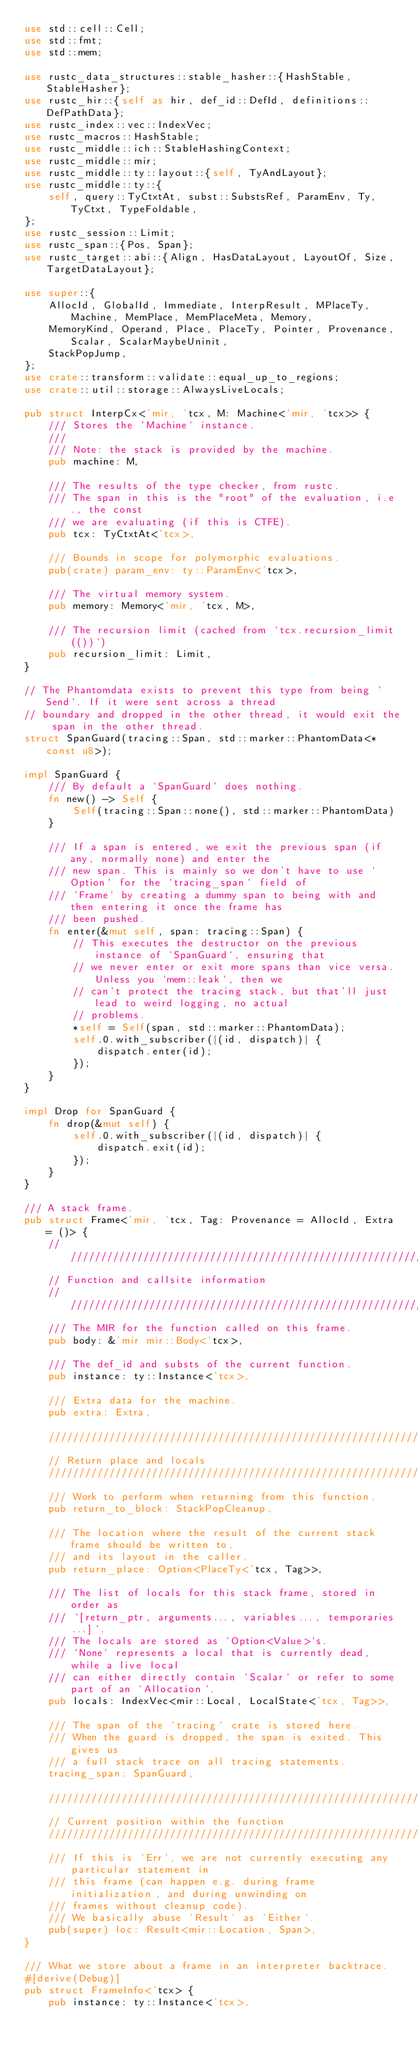Convert code to text. <code><loc_0><loc_0><loc_500><loc_500><_Rust_>use std::cell::Cell;
use std::fmt;
use std::mem;

use rustc_data_structures::stable_hasher::{HashStable, StableHasher};
use rustc_hir::{self as hir, def_id::DefId, definitions::DefPathData};
use rustc_index::vec::IndexVec;
use rustc_macros::HashStable;
use rustc_middle::ich::StableHashingContext;
use rustc_middle::mir;
use rustc_middle::ty::layout::{self, TyAndLayout};
use rustc_middle::ty::{
    self, query::TyCtxtAt, subst::SubstsRef, ParamEnv, Ty, TyCtxt, TypeFoldable,
};
use rustc_session::Limit;
use rustc_span::{Pos, Span};
use rustc_target::abi::{Align, HasDataLayout, LayoutOf, Size, TargetDataLayout};

use super::{
    AllocId, GlobalId, Immediate, InterpResult, MPlaceTy, Machine, MemPlace, MemPlaceMeta, Memory,
    MemoryKind, Operand, Place, PlaceTy, Pointer, Provenance, Scalar, ScalarMaybeUninit,
    StackPopJump,
};
use crate::transform::validate::equal_up_to_regions;
use crate::util::storage::AlwaysLiveLocals;

pub struct InterpCx<'mir, 'tcx, M: Machine<'mir, 'tcx>> {
    /// Stores the `Machine` instance.
    ///
    /// Note: the stack is provided by the machine.
    pub machine: M,

    /// The results of the type checker, from rustc.
    /// The span in this is the "root" of the evaluation, i.e., the const
    /// we are evaluating (if this is CTFE).
    pub tcx: TyCtxtAt<'tcx>,

    /// Bounds in scope for polymorphic evaluations.
    pub(crate) param_env: ty::ParamEnv<'tcx>,

    /// The virtual memory system.
    pub memory: Memory<'mir, 'tcx, M>,

    /// The recursion limit (cached from `tcx.recursion_limit(())`)
    pub recursion_limit: Limit,
}

// The Phantomdata exists to prevent this type from being `Send`. If it were sent across a thread
// boundary and dropped in the other thread, it would exit the span in the other thread.
struct SpanGuard(tracing::Span, std::marker::PhantomData<*const u8>);

impl SpanGuard {
    /// By default a `SpanGuard` does nothing.
    fn new() -> Self {
        Self(tracing::Span::none(), std::marker::PhantomData)
    }

    /// If a span is entered, we exit the previous span (if any, normally none) and enter the
    /// new span. This is mainly so we don't have to use `Option` for the `tracing_span` field of
    /// `Frame` by creating a dummy span to being with and then entering it once the frame has
    /// been pushed.
    fn enter(&mut self, span: tracing::Span) {
        // This executes the destructor on the previous instance of `SpanGuard`, ensuring that
        // we never enter or exit more spans than vice versa. Unless you `mem::leak`, then we
        // can't protect the tracing stack, but that'll just lead to weird logging, no actual
        // problems.
        *self = Self(span, std::marker::PhantomData);
        self.0.with_subscriber(|(id, dispatch)| {
            dispatch.enter(id);
        });
    }
}

impl Drop for SpanGuard {
    fn drop(&mut self) {
        self.0.with_subscriber(|(id, dispatch)| {
            dispatch.exit(id);
        });
    }
}

/// A stack frame.
pub struct Frame<'mir, 'tcx, Tag: Provenance = AllocId, Extra = ()> {
    ////////////////////////////////////////////////////////////////////////////////
    // Function and callsite information
    ////////////////////////////////////////////////////////////////////////////////
    /// The MIR for the function called on this frame.
    pub body: &'mir mir::Body<'tcx>,

    /// The def_id and substs of the current function.
    pub instance: ty::Instance<'tcx>,

    /// Extra data for the machine.
    pub extra: Extra,

    ////////////////////////////////////////////////////////////////////////////////
    // Return place and locals
    ////////////////////////////////////////////////////////////////////////////////
    /// Work to perform when returning from this function.
    pub return_to_block: StackPopCleanup,

    /// The location where the result of the current stack frame should be written to,
    /// and its layout in the caller.
    pub return_place: Option<PlaceTy<'tcx, Tag>>,

    /// The list of locals for this stack frame, stored in order as
    /// `[return_ptr, arguments..., variables..., temporaries...]`.
    /// The locals are stored as `Option<Value>`s.
    /// `None` represents a local that is currently dead, while a live local
    /// can either directly contain `Scalar` or refer to some part of an `Allocation`.
    pub locals: IndexVec<mir::Local, LocalState<'tcx, Tag>>,

    /// The span of the `tracing` crate is stored here.
    /// When the guard is dropped, the span is exited. This gives us
    /// a full stack trace on all tracing statements.
    tracing_span: SpanGuard,

    ////////////////////////////////////////////////////////////////////////////////
    // Current position within the function
    ////////////////////////////////////////////////////////////////////////////////
    /// If this is `Err`, we are not currently executing any particular statement in
    /// this frame (can happen e.g. during frame initialization, and during unwinding on
    /// frames without cleanup code).
    /// We basically abuse `Result` as `Either`.
    pub(super) loc: Result<mir::Location, Span>,
}

/// What we store about a frame in an interpreter backtrace.
#[derive(Debug)]
pub struct FrameInfo<'tcx> {
    pub instance: ty::Instance<'tcx>,</code> 